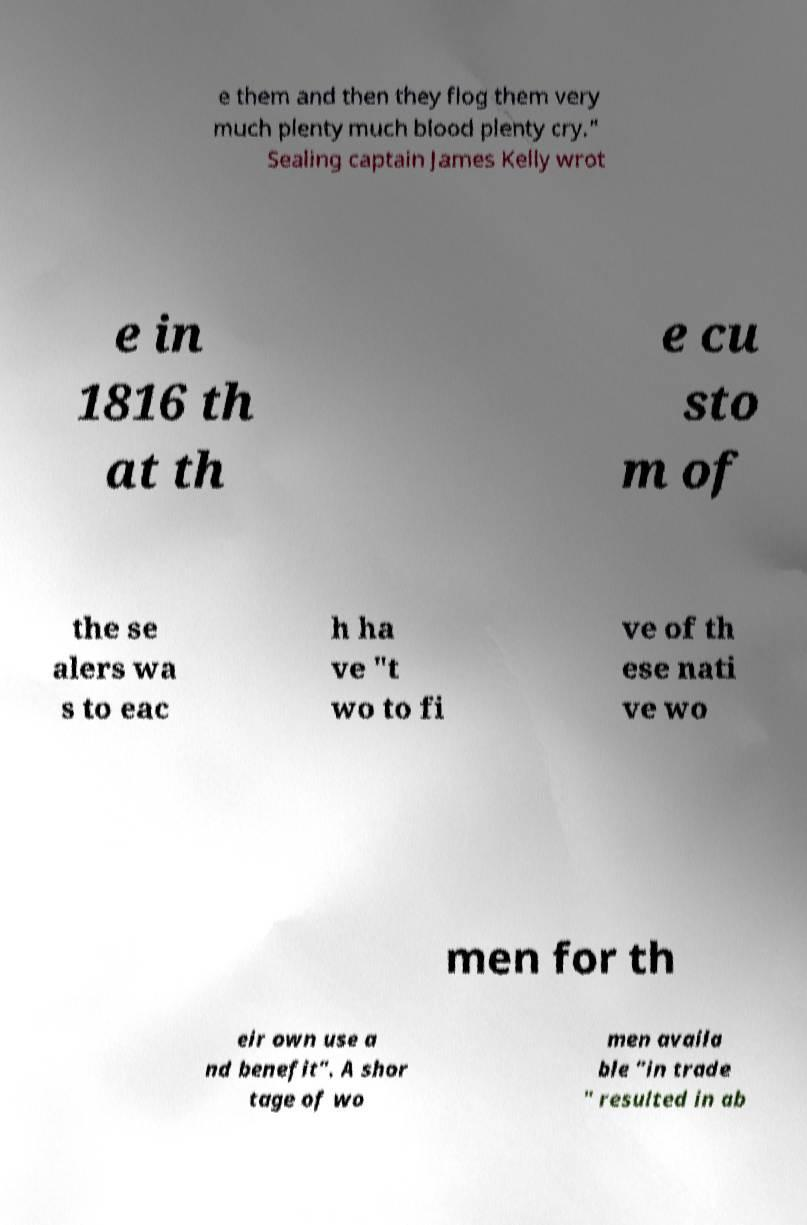What messages or text are displayed in this image? I need them in a readable, typed format. e them and then they flog them very much plenty much blood plenty cry." Sealing captain James Kelly wrot e in 1816 th at th e cu sto m of the se alers wa s to eac h ha ve "t wo to fi ve of th ese nati ve wo men for th eir own use a nd benefit". A shor tage of wo men availa ble "in trade " resulted in ab 